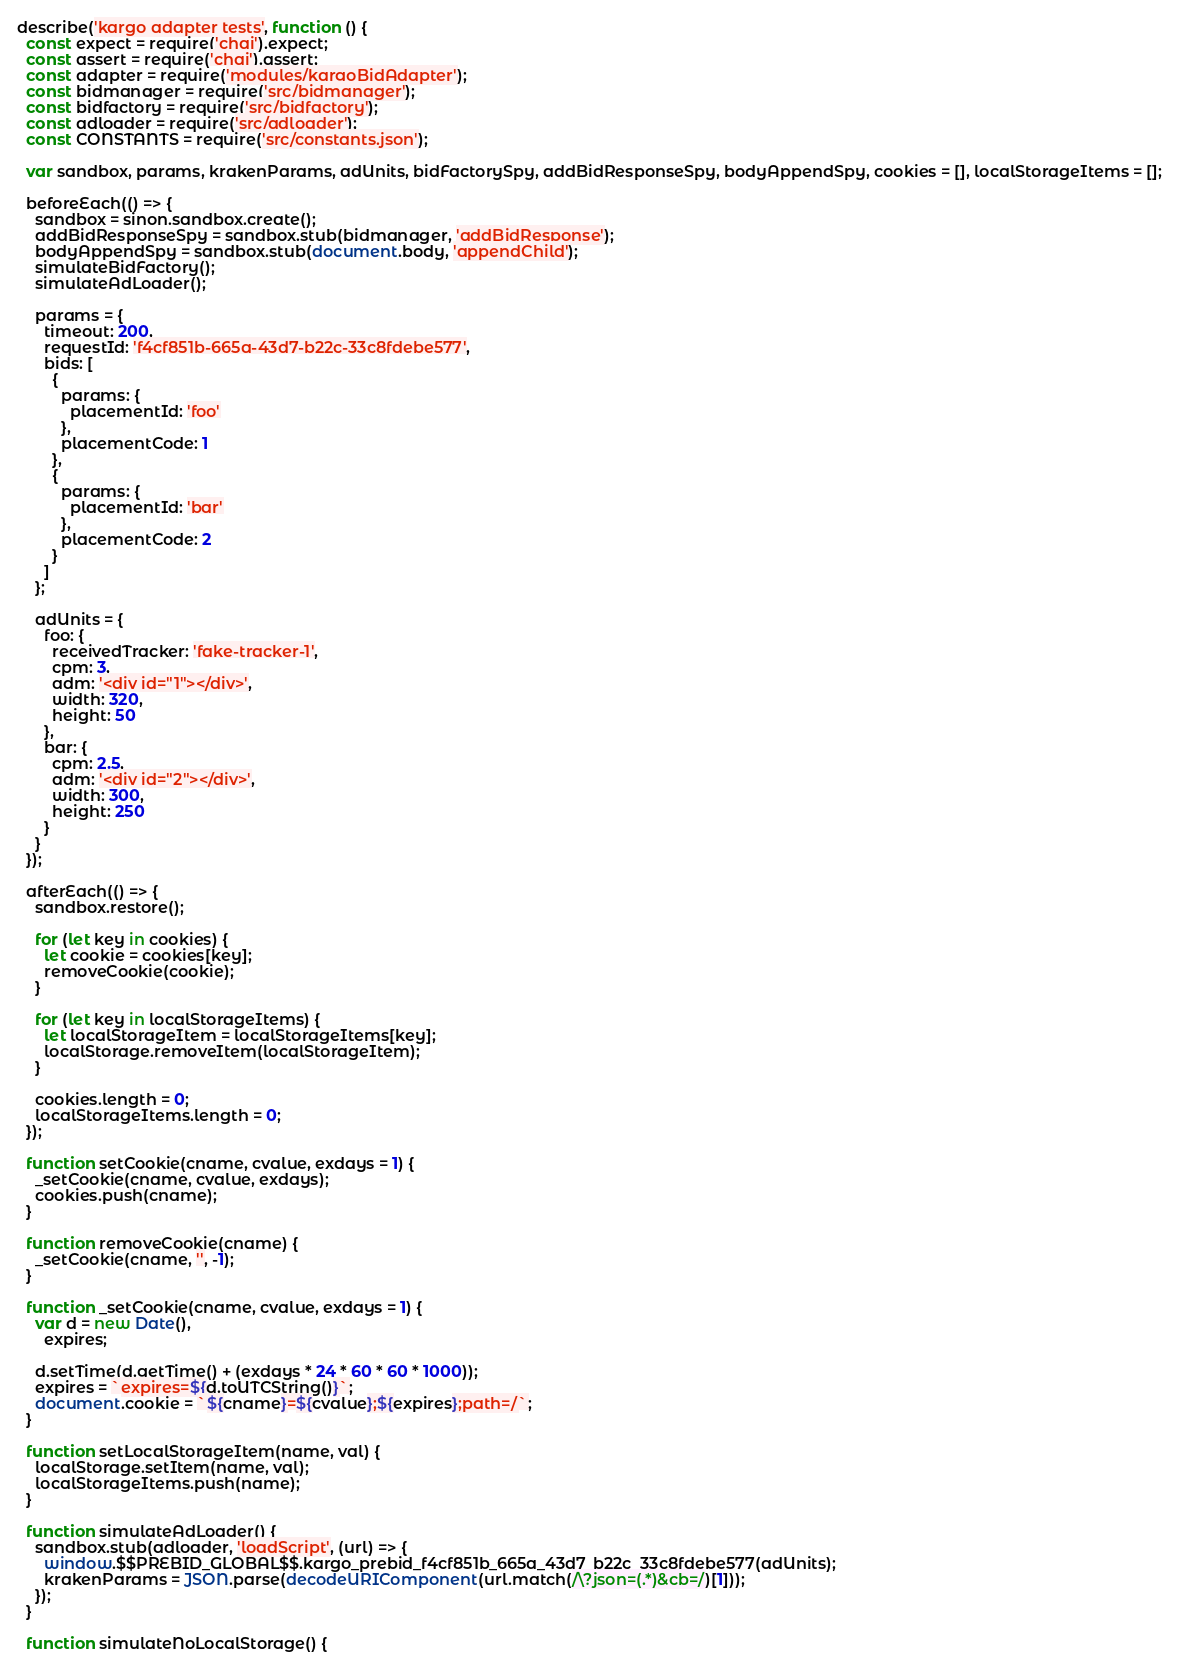<code> <loc_0><loc_0><loc_500><loc_500><_JavaScript_>describe('kargo adapter tests', function () {
  const expect = require('chai').expect;
  const assert = require('chai').assert;
  const adapter = require('modules/kargoBidAdapter');
  const bidmanager = require('src/bidmanager');
  const bidfactory = require('src/bidfactory');
  const adloader = require('src/adloader');
  const CONSTANTS = require('src/constants.json');

  var sandbox, params, krakenParams, adUnits, bidFactorySpy, addBidResponseSpy, bodyAppendSpy, cookies = [], localStorageItems = [];

  beforeEach(() => {
    sandbox = sinon.sandbox.create();
    addBidResponseSpy = sandbox.stub(bidmanager, 'addBidResponse');
    bodyAppendSpy = sandbox.stub(document.body, 'appendChild');
    simulateBidFactory();
    simulateAdLoader();

    params = {
      timeout: 200,
      requestId: 'f4cf851b-665a-43d7-b22c-33c8fdebe577',
      bids: [
        {
          params: {
            placementId: 'foo'
          },
          placementCode: 1
        },
        {
          params: {
            placementId: 'bar'
          },
          placementCode: 2
        }
      ]
    };

    adUnits = {
      foo: {
        receivedTracker: 'fake-tracker-1',
        cpm: 3,
        adm: '<div id="1"></div>',
        width: 320,
        height: 50
      },
      bar: {
        cpm: 2.5,
        adm: '<div id="2"></div>',
        width: 300,
        height: 250
      }
    }
  });

  afterEach(() => {
    sandbox.restore();

    for (let key in cookies) {
      let cookie = cookies[key];
      removeCookie(cookie);
    }

    for (let key in localStorageItems) {
      let localStorageItem = localStorageItems[key];
      localStorage.removeItem(localStorageItem);
    }

    cookies.length = 0;
    localStorageItems.length = 0;
  });

  function setCookie(cname, cvalue, exdays = 1) {
    _setCookie(cname, cvalue, exdays);
    cookies.push(cname);
  }

  function removeCookie(cname) {
    _setCookie(cname, '', -1);
  }

  function _setCookie(cname, cvalue, exdays = 1) {
    var d = new Date(),
      expires;

    d.setTime(d.getTime() + (exdays * 24 * 60 * 60 * 1000));
    expires = `expires=${d.toUTCString()}`;
    document.cookie = `${cname}=${cvalue};${expires};path=/`;
  }

  function setLocalStorageItem(name, val) {
    localStorage.setItem(name, val);
    localStorageItems.push(name);
  }

  function simulateAdLoader() {
    sandbox.stub(adloader, 'loadScript', (url) => {
      window.$$PREBID_GLOBAL$$.kargo_prebid_f4cf851b_665a_43d7_b22c_33c8fdebe577(adUnits);
      krakenParams = JSON.parse(decodeURIComponent(url.match(/\?json=(.*)&cb=/)[1]));
    });
  }

  function simulateNoLocalStorage() {</code> 